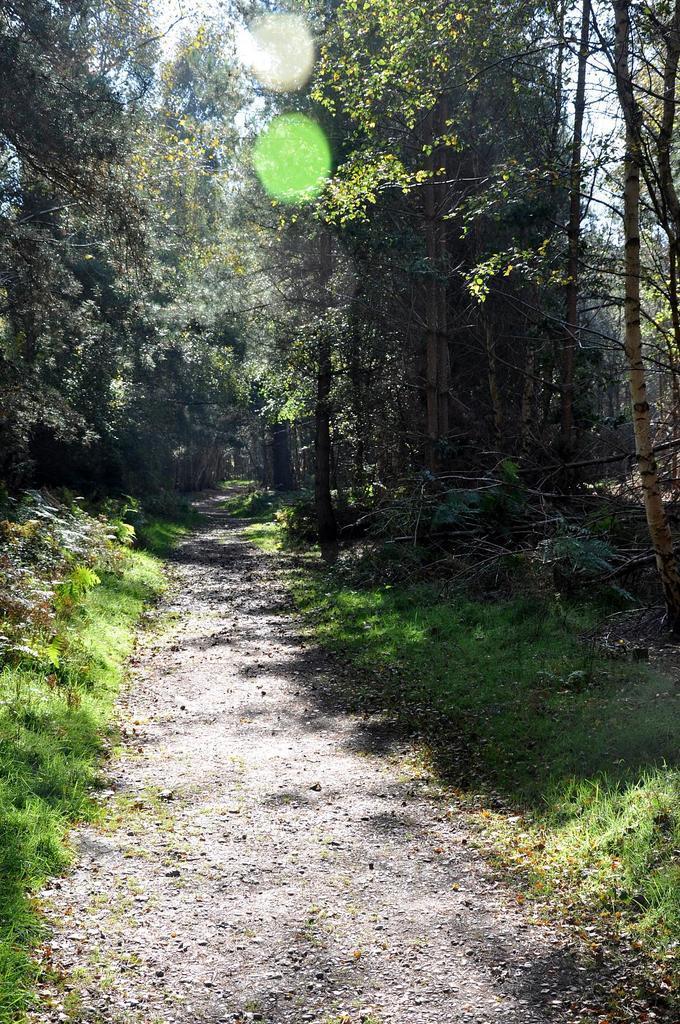Can you describe this image briefly? In this image there is a small road at bottom of this image and there are some trees in the background. 